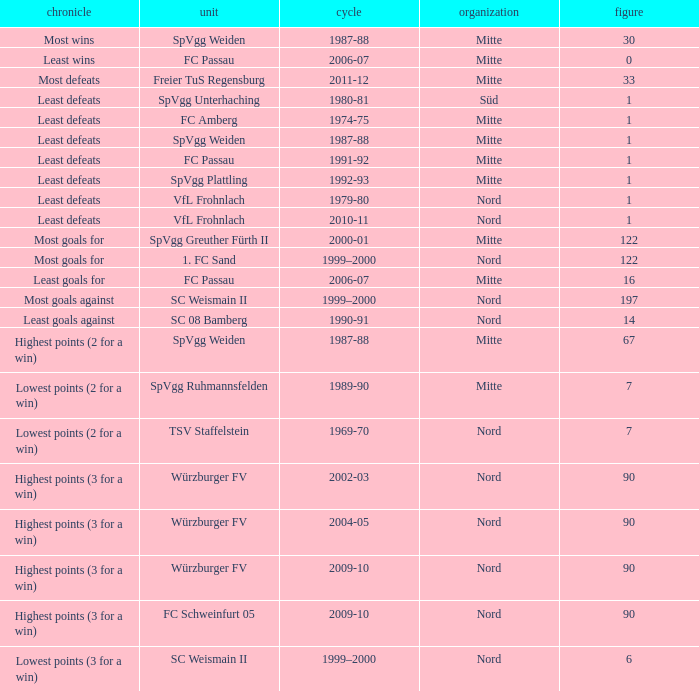What league has a number less than 122, and least wins as the record? Mitte. Can you parse all the data within this table? {'header': ['chronicle', 'unit', 'cycle', 'organization', 'figure'], 'rows': [['Most wins', 'SpVgg Weiden', '1987-88', 'Mitte', '30'], ['Least wins', 'FC Passau', '2006-07', 'Mitte', '0'], ['Most defeats', 'Freier TuS Regensburg', '2011-12', 'Mitte', '33'], ['Least defeats', 'SpVgg Unterhaching', '1980-81', 'Süd', '1'], ['Least defeats', 'FC Amberg', '1974-75', 'Mitte', '1'], ['Least defeats', 'SpVgg Weiden', '1987-88', 'Mitte', '1'], ['Least defeats', 'FC Passau', '1991-92', 'Mitte', '1'], ['Least defeats', 'SpVgg Plattling', '1992-93', 'Mitte', '1'], ['Least defeats', 'VfL Frohnlach', '1979-80', 'Nord', '1'], ['Least defeats', 'VfL Frohnlach', '2010-11', 'Nord', '1'], ['Most goals for', 'SpVgg Greuther Fürth II', '2000-01', 'Mitte', '122'], ['Most goals for', '1. FC Sand', '1999–2000', 'Nord', '122'], ['Least goals for', 'FC Passau', '2006-07', 'Mitte', '16'], ['Most goals against', 'SC Weismain II', '1999–2000', 'Nord', '197'], ['Least goals against', 'SC 08 Bamberg', '1990-91', 'Nord', '14'], ['Highest points (2 for a win)', 'SpVgg Weiden', '1987-88', 'Mitte', '67'], ['Lowest points (2 for a win)', 'SpVgg Ruhmannsfelden', '1989-90', 'Mitte', '7'], ['Lowest points (2 for a win)', 'TSV Staffelstein', '1969-70', 'Nord', '7'], ['Highest points (3 for a win)', 'Würzburger FV', '2002-03', 'Nord', '90'], ['Highest points (3 for a win)', 'Würzburger FV', '2004-05', 'Nord', '90'], ['Highest points (3 for a win)', 'Würzburger FV', '2009-10', 'Nord', '90'], ['Highest points (3 for a win)', 'FC Schweinfurt 05', '2009-10', 'Nord', '90'], ['Lowest points (3 for a win)', 'SC Weismain II', '1999–2000', 'Nord', '6']]} 